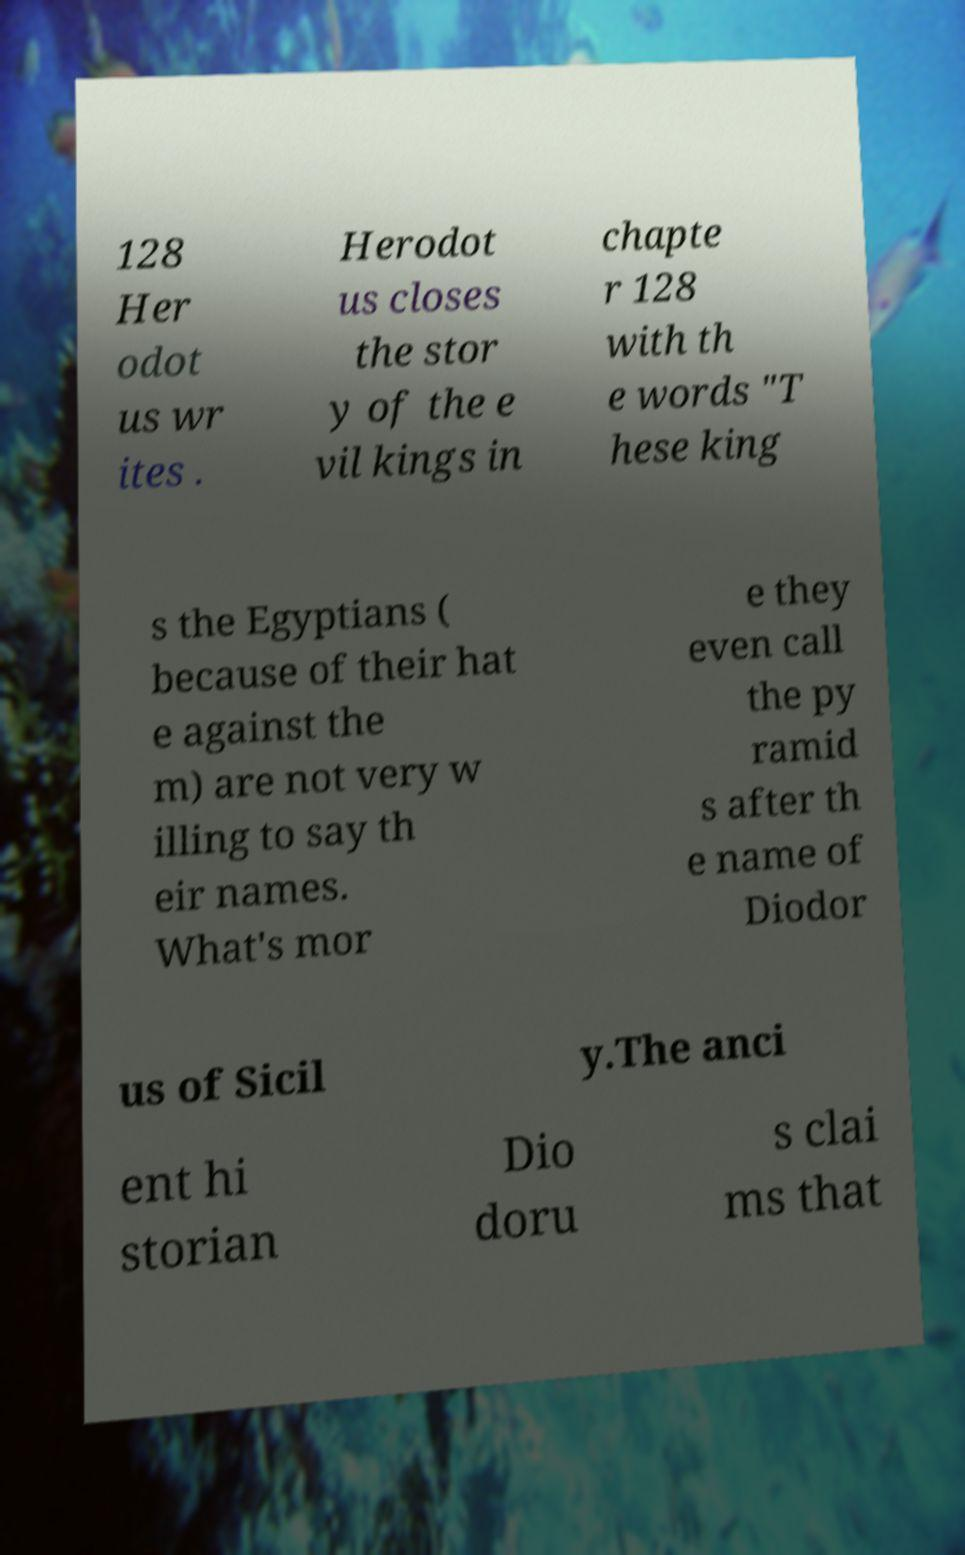Could you extract and type out the text from this image? 128 Her odot us wr ites . Herodot us closes the stor y of the e vil kings in chapte r 128 with th e words "T hese king s the Egyptians ( because of their hat e against the m) are not very w illing to say th eir names. What's mor e they even call the py ramid s after th e name of Diodor us of Sicil y.The anci ent hi storian Dio doru s clai ms that 